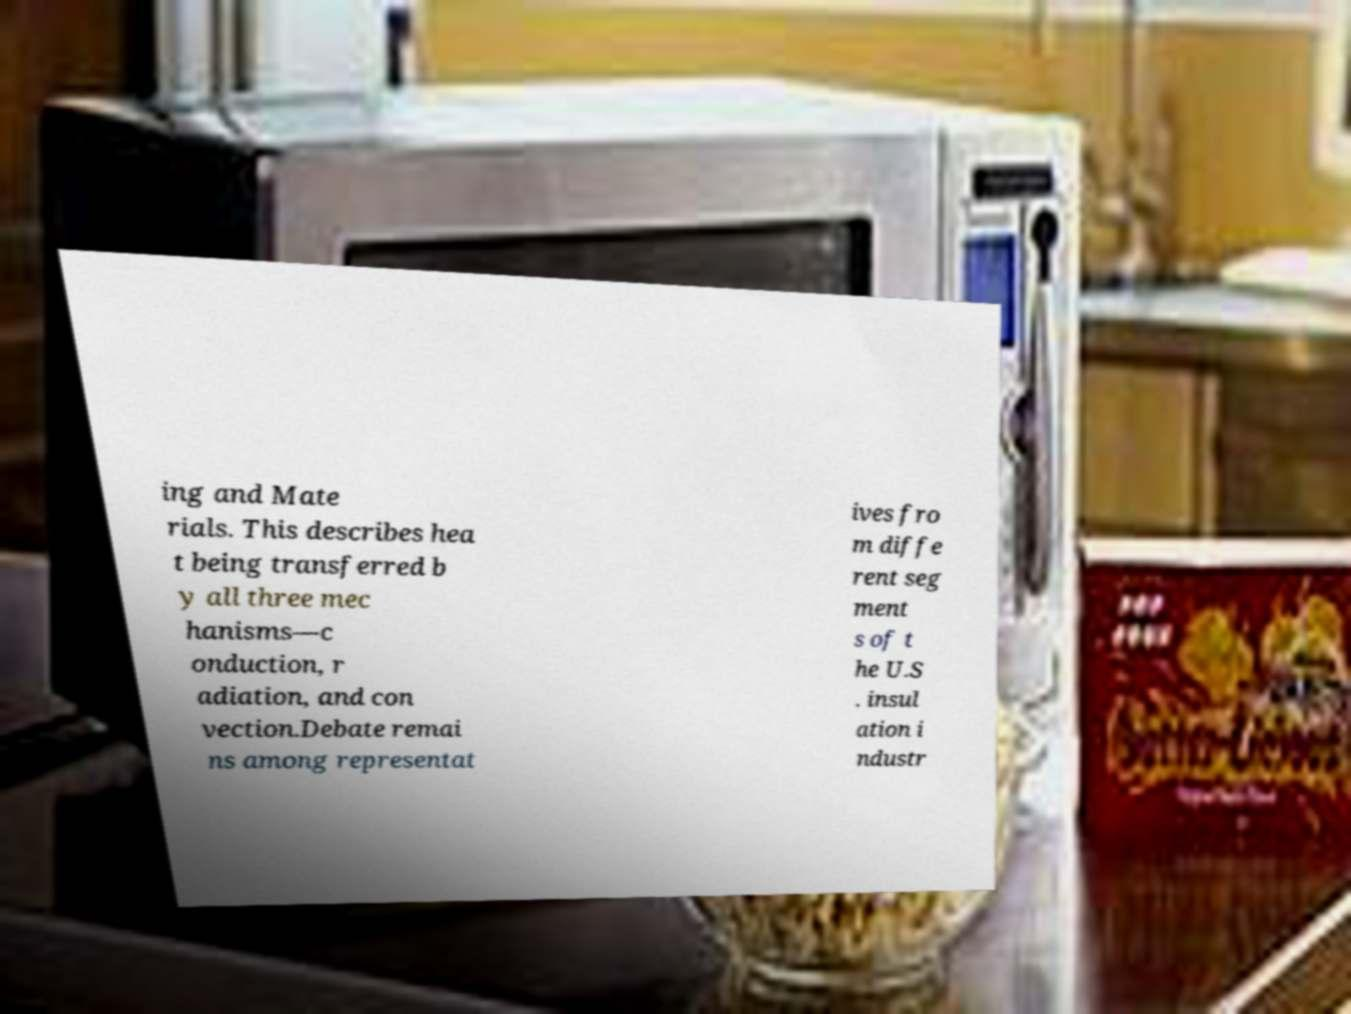There's text embedded in this image that I need extracted. Can you transcribe it verbatim? ing and Mate rials. This describes hea t being transferred b y all three mec hanisms—c onduction, r adiation, and con vection.Debate remai ns among representat ives fro m diffe rent seg ment s of t he U.S . insul ation i ndustr 